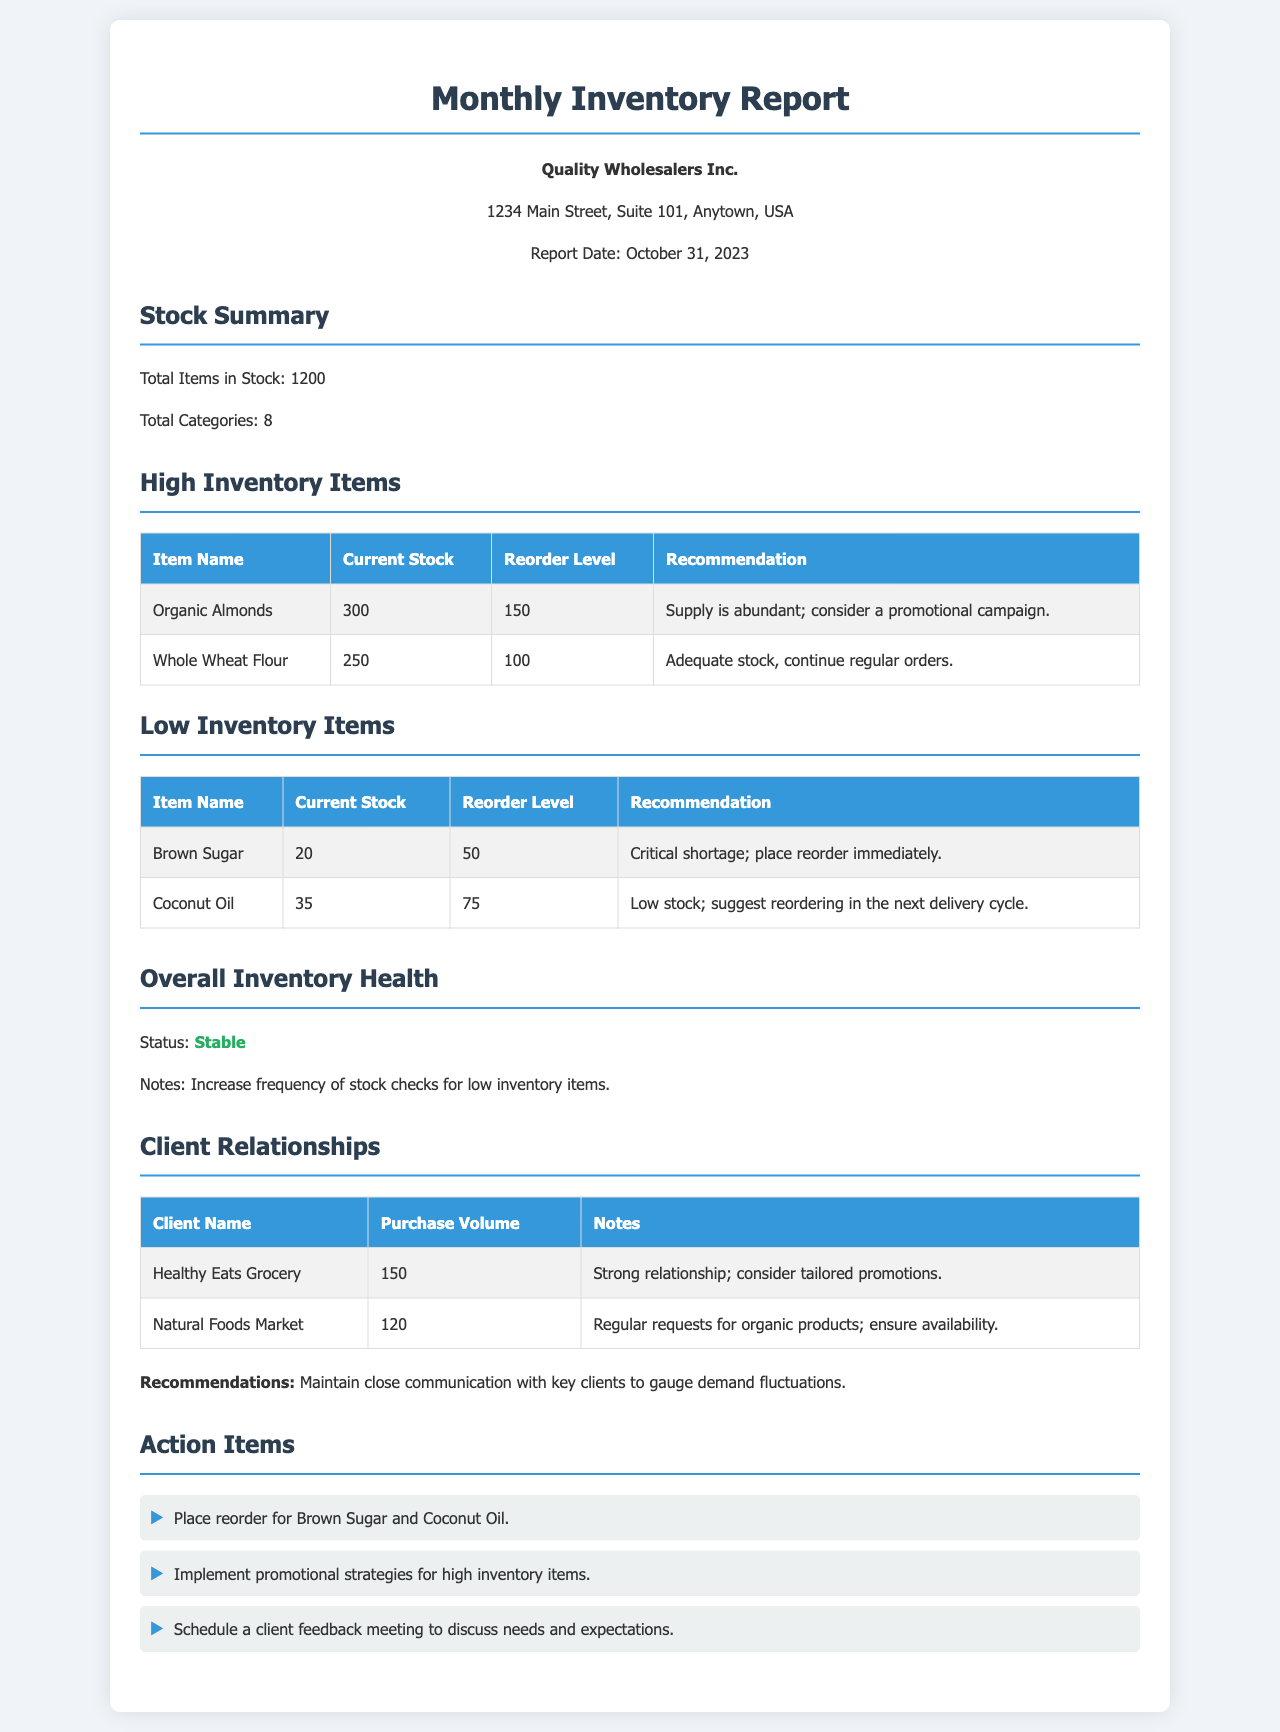What is the report date? The report date is specified at the top of the document under the header, which is October 31, 2023.
Answer: October 31, 2023 How many total items are in stock? The total number of items in stock is provided in the stock summary section, which states there are 1200 items.
Answer: 1200 What is the current stock level of Organic Almonds? The current stock level for Organic Almonds is listed in the high inventory items table, which is 300.
Answer: 300 What recommendations are made for Brown Sugar? The recommendation for Brown Sugar is detailed in the low inventory items table, which states there is a critical shortage.
Answer: Place reorder immediately What is the overall inventory status? The overall inventory status is summarized in the inventory health section, indicating stability in the stock levels.
Answer: Stable How many low inventory items are listed? The document includes a count of low inventory items, which are listed in one section, indicating there are 2 items.
Answer: 2 What is the purchase volume for Healthy Eats Grocery? The purchase volume for Healthy Eats Grocery is indicated in the client relationships table, which states 150.
Answer: 150 What action item involves client feedback? The action items listed pertain to scheduling a meeting for client feedback, aimed at discussing needs and expectations.
Answer: Schedule a client feedback meeting What is the recommendation for high inventory items? The recommendation for high inventory items is noted under the high inventory items section, which suggests implementing promotional strategies.
Answer: Implement promotional strategies 